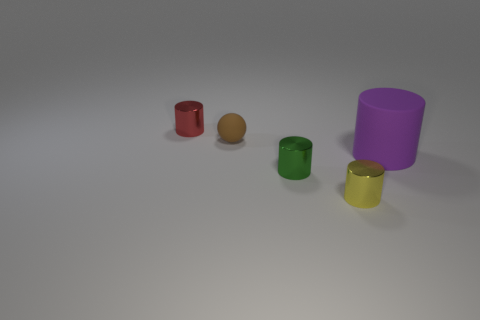Add 5 green cylinders. How many objects exist? 10 Subtract all balls. How many objects are left? 4 Subtract 0 brown cubes. How many objects are left? 5 Subtract all brown shiny objects. Subtract all yellow shiny cylinders. How many objects are left? 4 Add 4 small brown balls. How many small brown balls are left? 5 Add 5 purple matte balls. How many purple matte balls exist? 5 